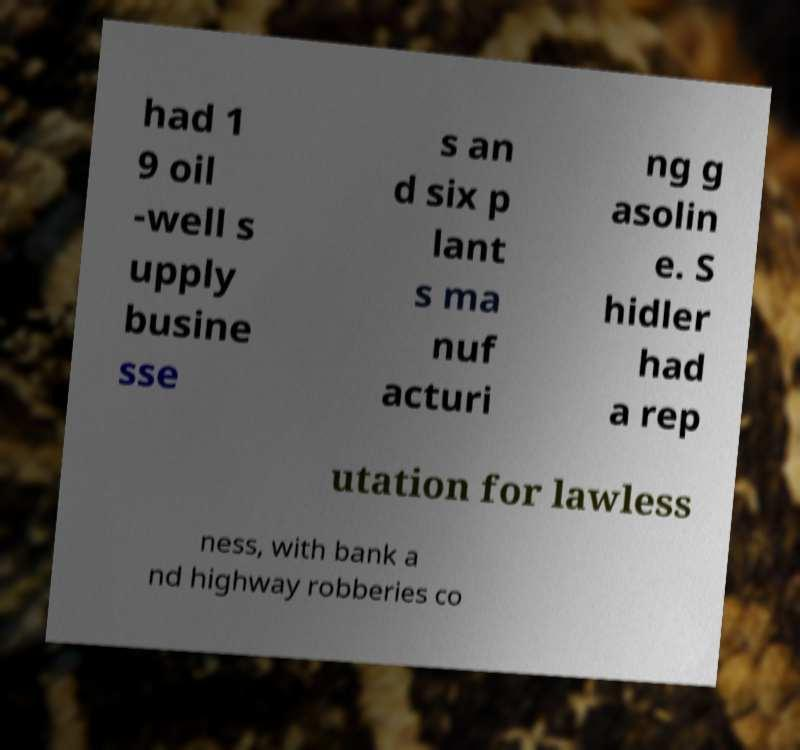I need the written content from this picture converted into text. Can you do that? had 1 9 oil -well s upply busine sse s an d six p lant s ma nuf acturi ng g asolin e. S hidler had a rep utation for lawless ness, with bank a nd highway robberies co 